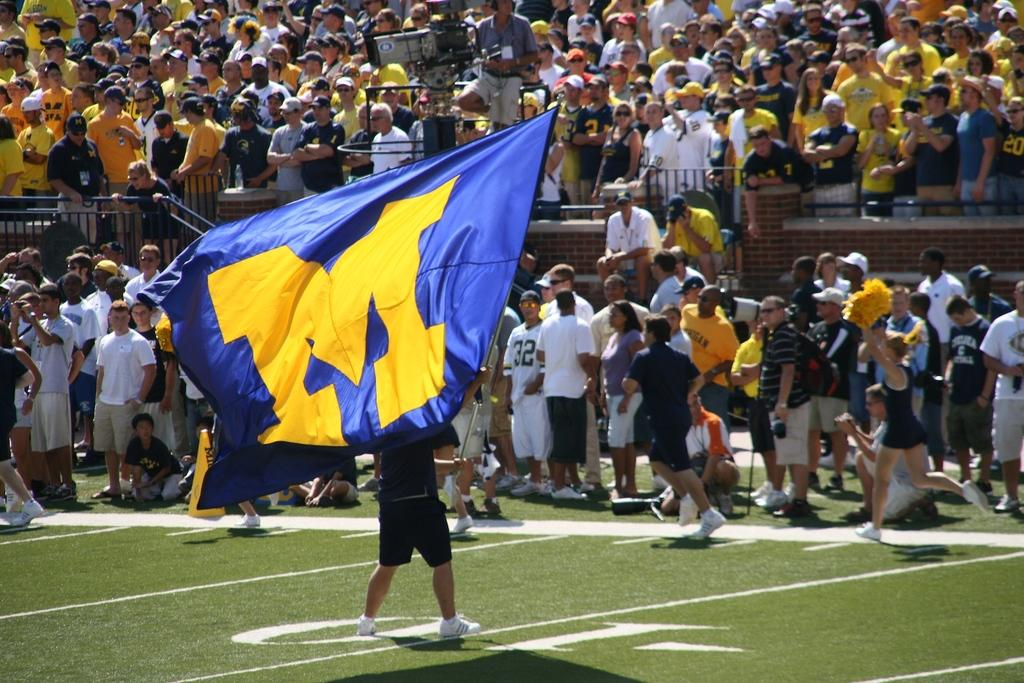<image>
Give a short and clear explanation of the subsequent image. Someone stands on the sports field with a flag with the letter M on it. 